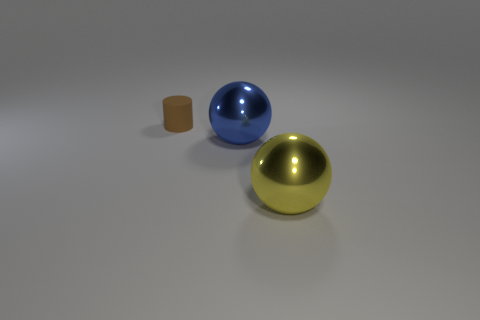Add 3 tiny purple metal spheres. How many objects exist? 6 Subtract all balls. How many objects are left? 1 Subtract 0 yellow cylinders. How many objects are left? 3 Subtract all small brown shiny things. Subtract all large blue metallic things. How many objects are left? 2 Add 1 tiny brown matte things. How many tiny brown matte things are left? 2 Add 1 brown metal blocks. How many brown metal blocks exist? 1 